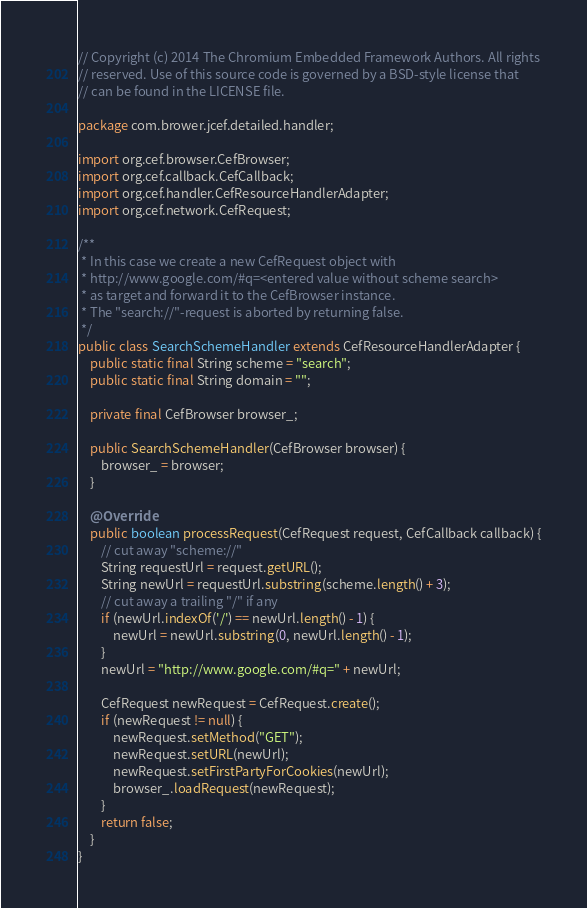<code> <loc_0><loc_0><loc_500><loc_500><_Java_>// Copyright (c) 2014 The Chromium Embedded Framework Authors. All rights
// reserved. Use of this source code is governed by a BSD-style license that
// can be found in the LICENSE file.

package com.brower.jcef.detailed.handler;

import org.cef.browser.CefBrowser;
import org.cef.callback.CefCallback;
import org.cef.handler.CefResourceHandlerAdapter;
import org.cef.network.CefRequest;

/**
 * In this case we create a new CefRequest object with
 * http://www.google.com/#q=<entered value without scheme search>
 * as target and forward it to the CefBrowser instance.
 * The "search://"-request is aborted by returning false.
 */
public class SearchSchemeHandler extends CefResourceHandlerAdapter {
    public static final String scheme = "search";
    public static final String domain = "";

    private final CefBrowser browser_;

    public SearchSchemeHandler(CefBrowser browser) {
        browser_ = browser;
    }

    @Override
    public boolean processRequest(CefRequest request, CefCallback callback) {
        // cut away "scheme://"
        String requestUrl = request.getURL();
        String newUrl = requestUrl.substring(scheme.length() + 3);
        // cut away a trailing "/" if any
        if (newUrl.indexOf('/') == newUrl.length() - 1) {
            newUrl = newUrl.substring(0, newUrl.length() - 1);
        }
        newUrl = "http://www.google.com/#q=" + newUrl;

        CefRequest newRequest = CefRequest.create();
        if (newRequest != null) {
            newRequest.setMethod("GET");
            newRequest.setURL(newUrl);
            newRequest.setFirstPartyForCookies(newUrl);
            browser_.loadRequest(newRequest);
        }
        return false;
    }
}
</code> 